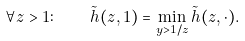Convert formula to latex. <formula><loc_0><loc_0><loc_500><loc_500>\forall z > 1 \colon \quad \tilde { h } ( z , 1 ) = \min _ { y > 1 / z } \tilde { h } ( z , \cdot ) .</formula> 